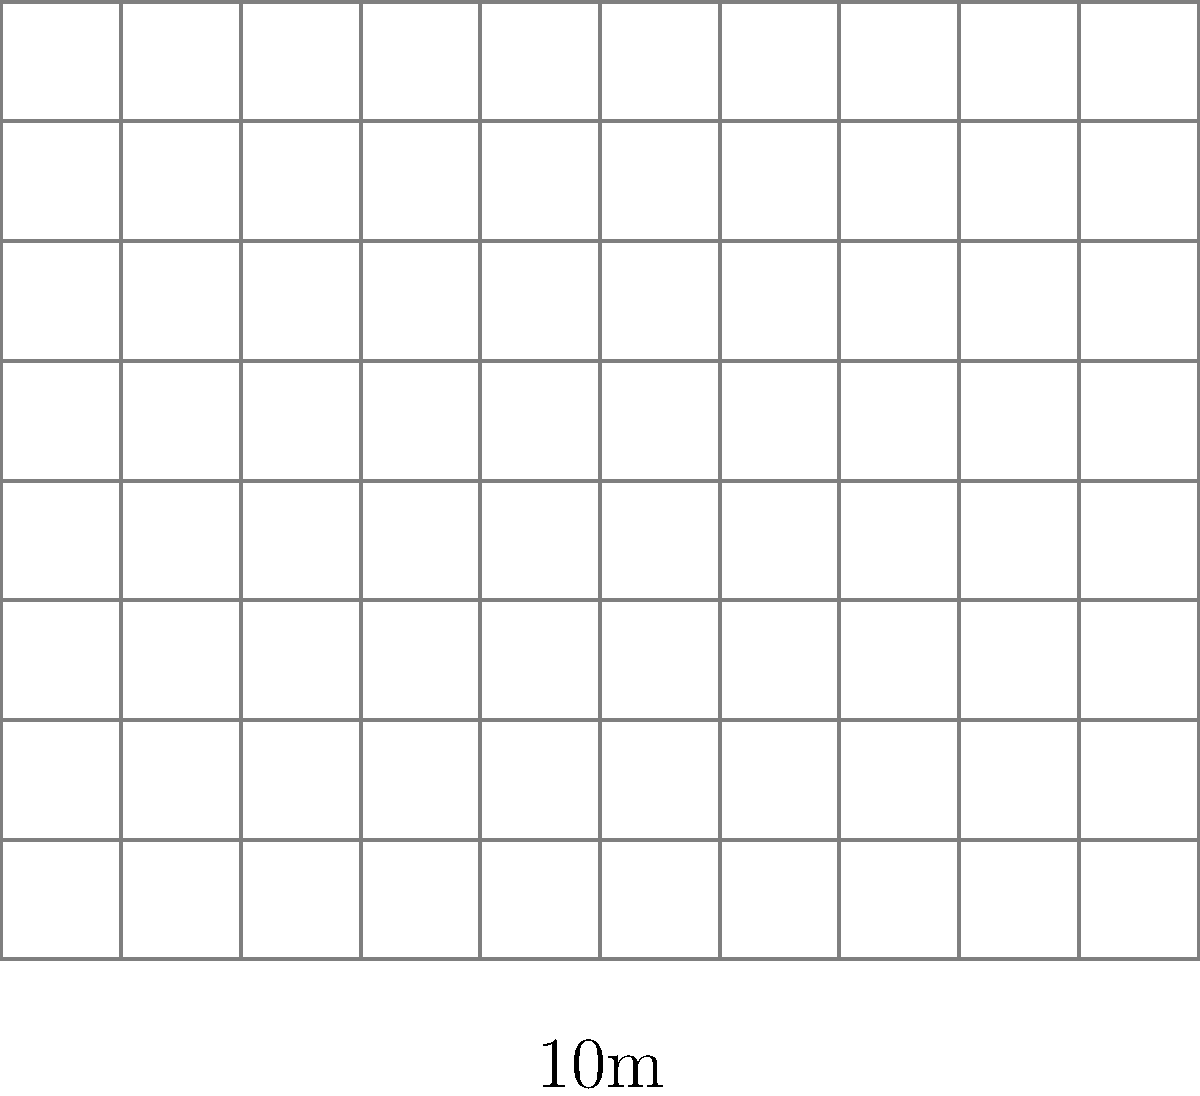As a security guard, you're tasked with estimating the crowd size at an outdoor event. The aerial diagram shows a 100m x 80m area with each grid square representing 10m x 10m. Red dots indicate individuals. Based on this information, what's your best estimate of the total number of people in the entire area? Let's approach this step-by-step:

1. First, we need to count the number of red dots (people) in the diagram. There are 20 red dots visible.

2. The diagram shows a sample of the entire area. We need to determine what fraction of the total area this sample represents.

3. The entire area is 100m x 80m = 8000 square meters.

4. The diagram is divided into a 10x8 grid, with each grid square representing 10m x 10m = 100 square meters.

5. The total number of grid squares is 10 x 8 = 80 squares.

6. So, the total area represented by the diagram is 80 x 100 = 8000 square meters, which is the entire area.

7. This means the 20 people we can see represent the total number of people in the area.

8. As a security guard, it's always better to slightly overestimate for safety reasons. We might round up to 25 to account for any potential oversight or movement.

Therefore, a reasonable estimate for the total number of people in the area would be about 25 people.
Answer: Approximately 25 people 